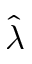Convert formula to latex. <formula><loc_0><loc_0><loc_500><loc_500>\hat { \lambda }</formula> 